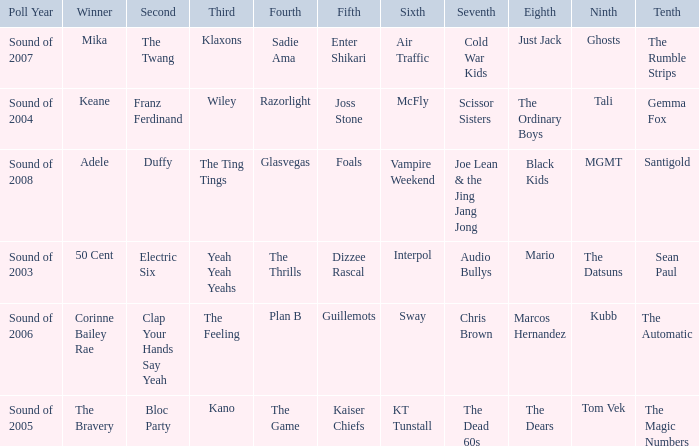When Interpol is in 6th, who is in 7th? 1.0. 